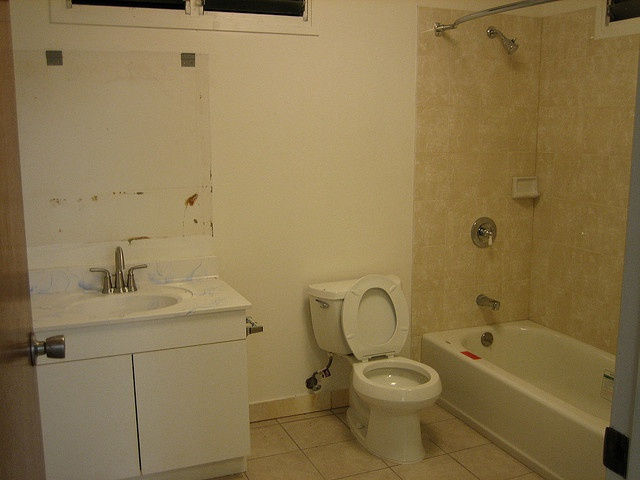Describe the objects in this image and their specific colors. I can see toilet in maroon, tan, and olive tones, sink in maroon, tan, gray, and olive tones, and sink in maroon and olive tones in this image. 